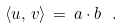<formula> <loc_0><loc_0><loc_500><loc_500>\langle { u } , \, { v } \rangle \, = \, a \cdot b \ .</formula> 